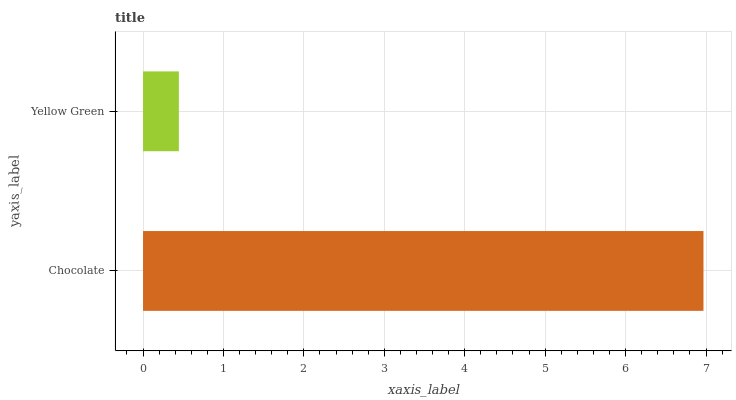Is Yellow Green the minimum?
Answer yes or no. Yes. Is Chocolate the maximum?
Answer yes or no. Yes. Is Yellow Green the maximum?
Answer yes or no. No. Is Chocolate greater than Yellow Green?
Answer yes or no. Yes. Is Yellow Green less than Chocolate?
Answer yes or no. Yes. Is Yellow Green greater than Chocolate?
Answer yes or no. No. Is Chocolate less than Yellow Green?
Answer yes or no. No. Is Chocolate the high median?
Answer yes or no. Yes. Is Yellow Green the low median?
Answer yes or no. Yes. Is Yellow Green the high median?
Answer yes or no. No. Is Chocolate the low median?
Answer yes or no. No. 